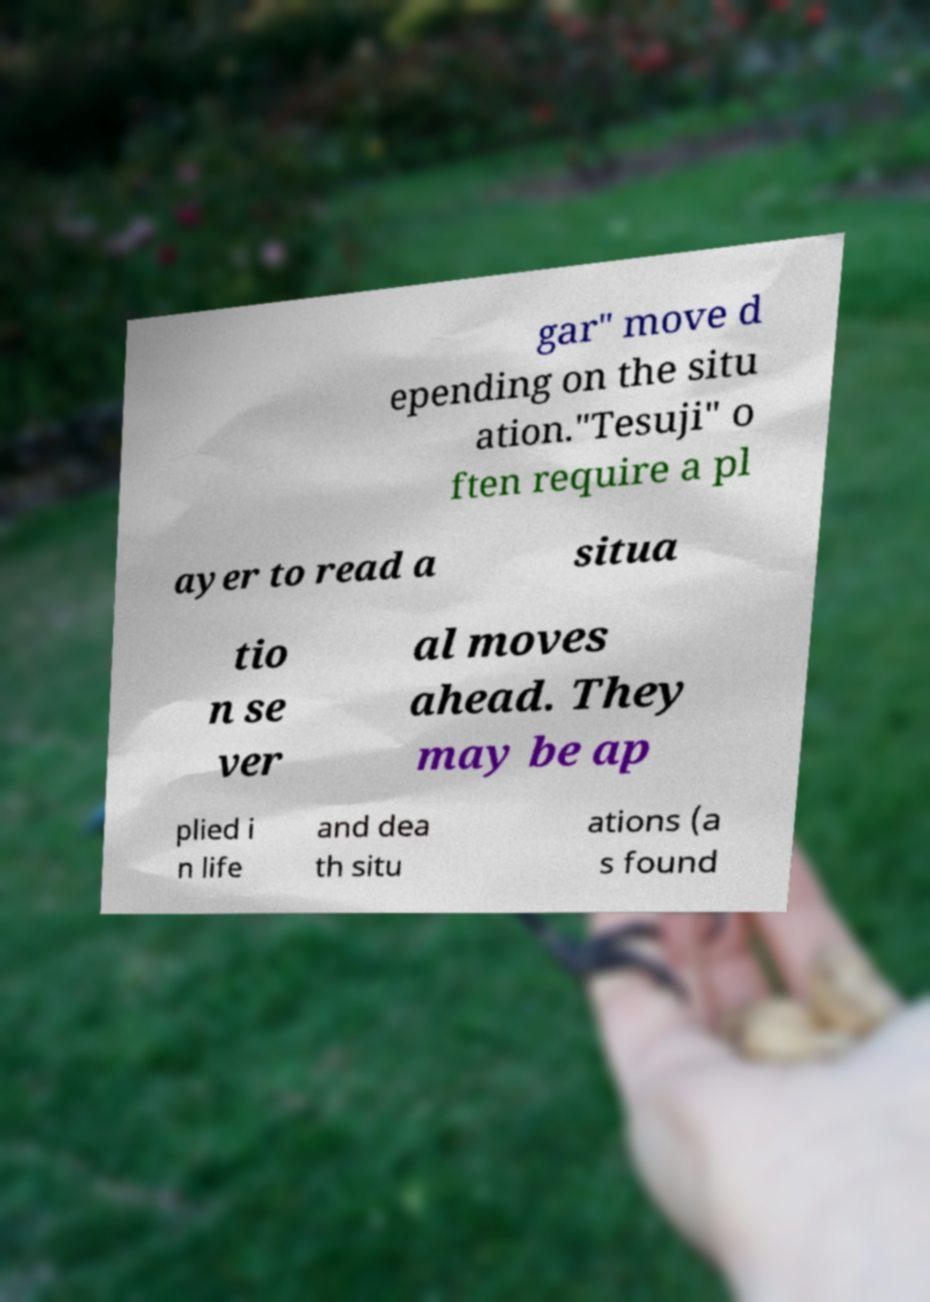What messages or text are displayed in this image? I need them in a readable, typed format. gar" move d epending on the situ ation."Tesuji" o ften require a pl ayer to read a situa tio n se ver al moves ahead. They may be ap plied i n life and dea th situ ations (a s found 